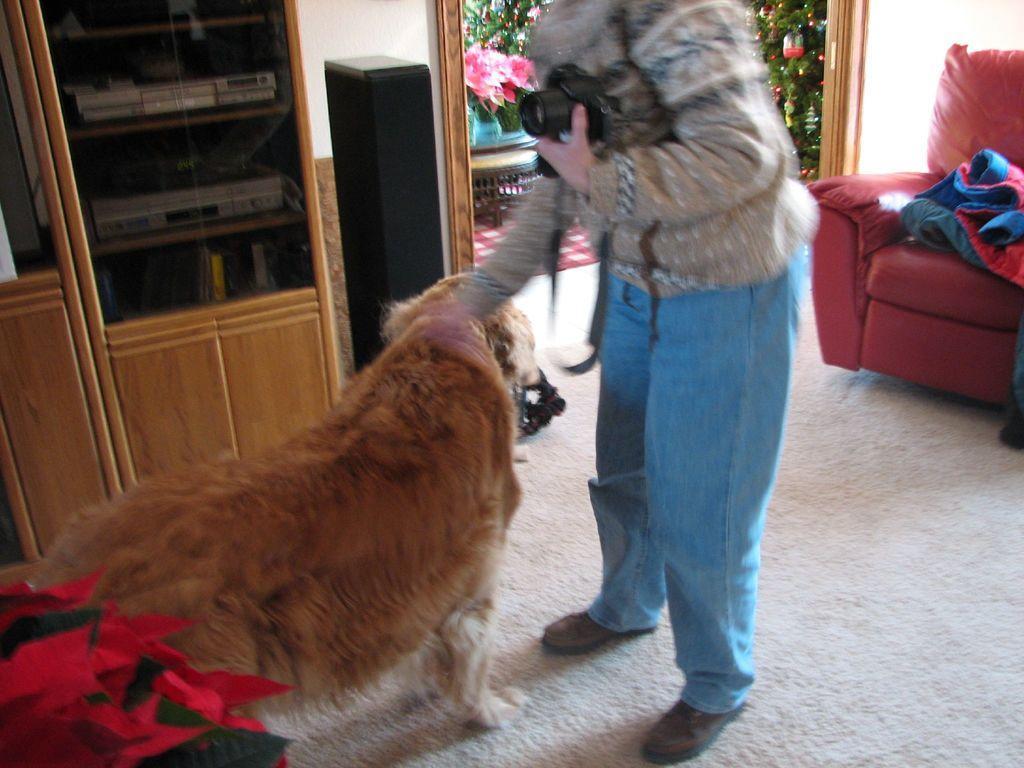In one or two sentences, can you explain what this image depicts? In this picture there is a woman standing holding a camera in her hand. There is a dog in front of her. Behind the dog there is a cupboard, speaker. In the right side there is a sofa. In the background there are some trees. 